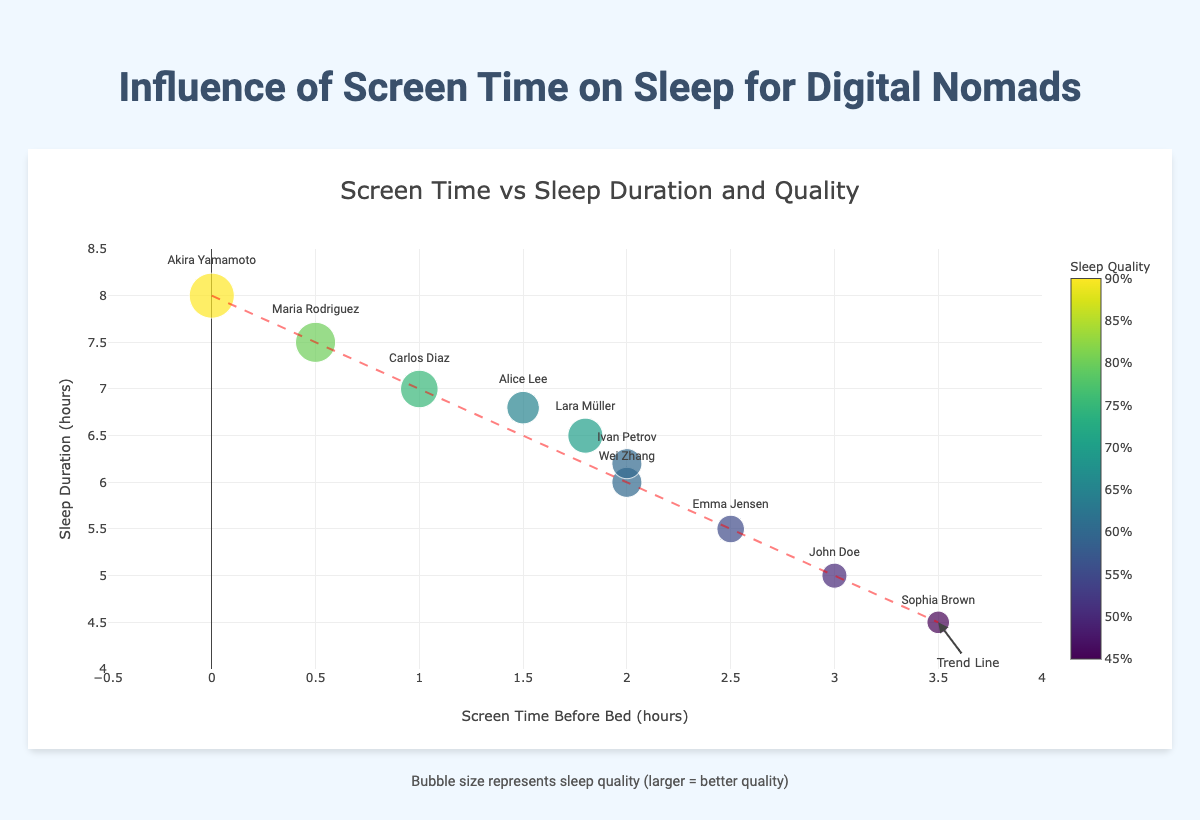What is the average screen time before bed among the digital nomads? Add up all the screen times before bed for each nomad and divide by the number of nomads. The sum is 1.5 + 3.0 + 0.5 + 2.0 + 0.0 + 2.5 + 1.0 + 3.5 + 2.0 + 1.8 = 17.8. There are 10 nomads, so the average is 17.8 / 10 = 1.78 hours.
Answer: 1.78 Which digital nomad has the highest sleep quality, and what is their screen time before bed? Look for the bubble with the largest size and highest color value representing the best sleep quality. Akira Yamamoto has the highest sleep quality of 90%, and their screen time before bed is 0.0 hours.
Answer: Akira Yamamoto, 0.0 hours Compare the sleep duration of John Doe and Maria Rodriguez. Who has a longer sleep duration, and by how much? John Doe's sleep duration is 5.0 hours, and Maria Rodriguez's sleep duration is 7.5 hours. Subtract John Doe's sleep duration from Maria Rodriguez's: 7.5 - 5.0 = 2.5 hours.
Answer: Maria Rodriguez, 2.5 hours What trend does the line in the plot indicate about the relationship between screen time before bed and sleep duration? The line trends downwards from left to right, indicating that as screen time before bed increases, sleep duration tends to decrease.
Answer: Increase in screen time decreases sleep Who has the most and least screen time before bed, and what are their sleep qualities? Akira Yamamoto has the least screen time before bed (0.0 hours) with a sleep quality of 90%. Sophia Brown has the most screen time before bed (3.5 hours) with a sleep quality of 45%.
Answer: Akira Yamamoto: 90%, Sophia Brown: 45% Calculate the mean sleep quality of digital nomads with screen time before bed less than 2 hours. List those with screen time less than 2 hours: Alice Lee (65), Maria Rodriguez (80), Akira Yamamoto (90), Carlos Diaz (75). The sum of their sleep qualities is 65 + 80 + 90 + 75 = 310. Divide by the number of nomads (4): 310 / 4 = 77.5%.
Answer: 77.5% Identify the digital nomad whose sleep duration is roughly halfway between the highest and lowest observed sleep durations and state their screen time before bed. The highest sleep duration is Akira Yamamoto's 8.0 hours, and the lowest is Sophia Brown's 4.5 hours. The mid-point is (8.0 + 4.5) / 2 = 6.25 hours. Ivan Petrov has a sleep duration of 6.2 hours, which is closest to 6.25 hours, with a screen time of 2.0 hours.
Answer: Ivan Petrov, 2.0 hours How does Wei Zhang’s sleep quality compare to Lara Müller’s sleep quality? Wei Zhang and Lara Müller both have a sleep quality of 60, meaning their sleep quality is equal.
Answer: They are equal Which digital nomad has the lowest sleep duration and what is their screen time before bed? Sophia Brown has the lowest sleep duration of 4.5 hours and her screen time before bed is 3.5 hours.
Answer: Sophia Brown, 3.5 hours 